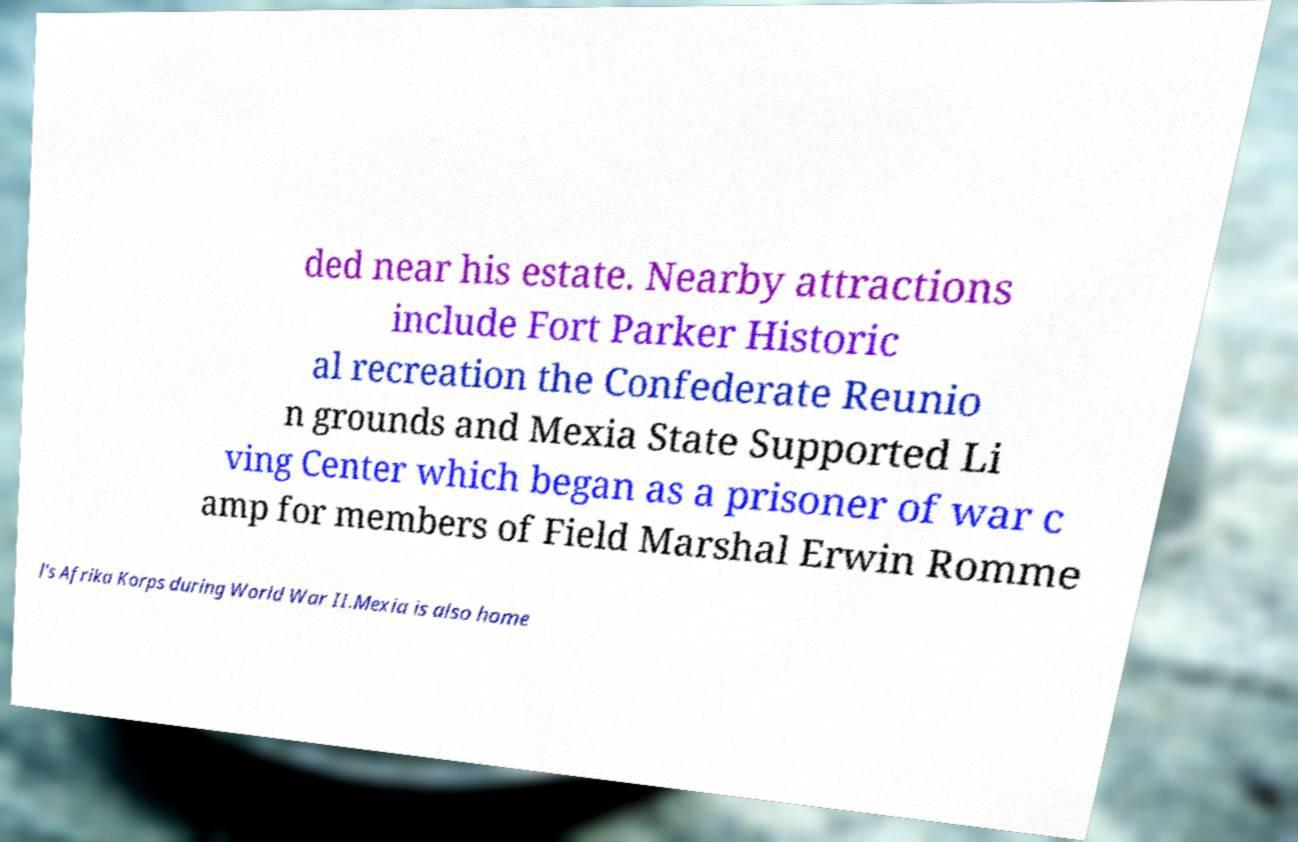Could you assist in decoding the text presented in this image and type it out clearly? ded near his estate. Nearby attractions include Fort Parker Historic al recreation the Confederate Reunio n grounds and Mexia State Supported Li ving Center which began as a prisoner of war c amp for members of Field Marshal Erwin Romme l's Afrika Korps during World War II.Mexia is also home 